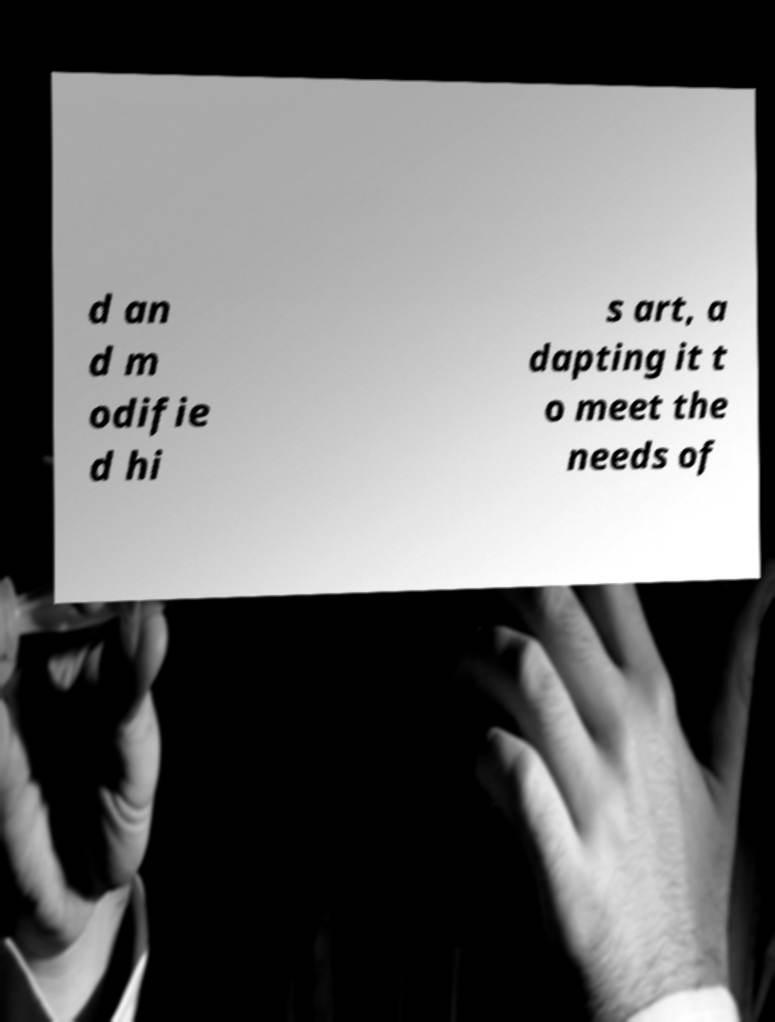Could you extract and type out the text from this image? d an d m odifie d hi s art, a dapting it t o meet the needs of 